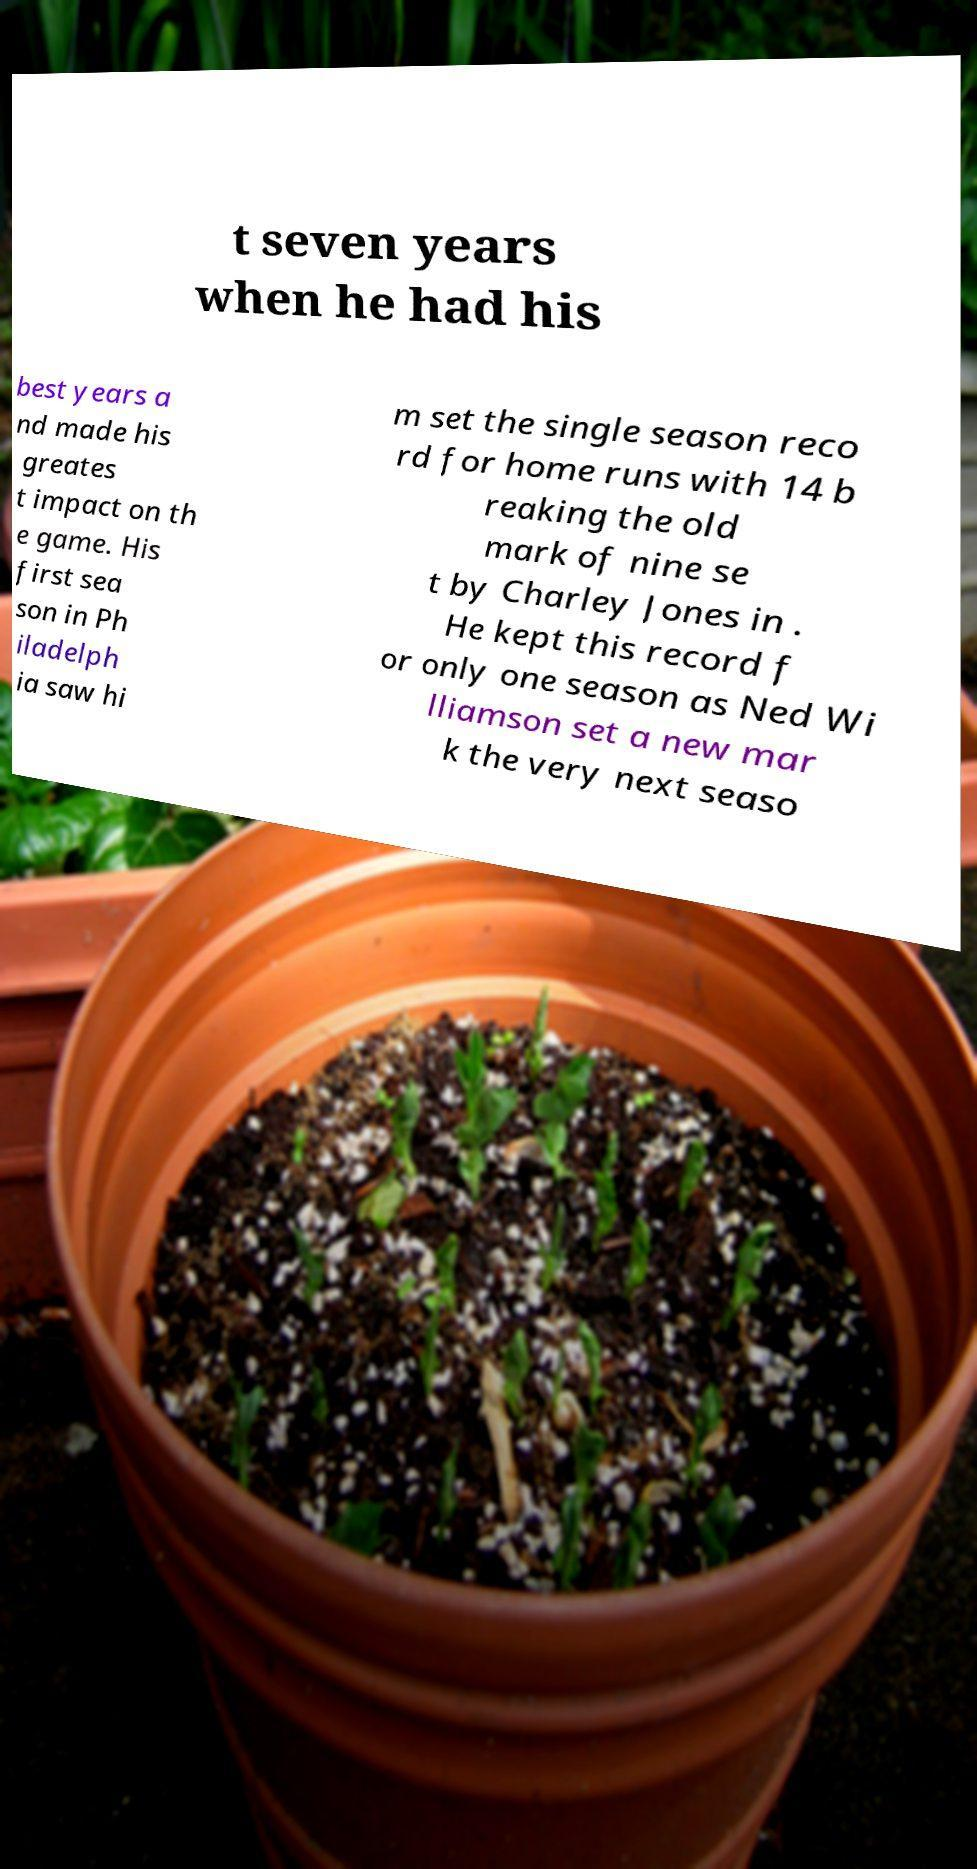For documentation purposes, I need the text within this image transcribed. Could you provide that? t seven years when he had his best years a nd made his greates t impact on th e game. His first sea son in Ph iladelph ia saw hi m set the single season reco rd for home runs with 14 b reaking the old mark of nine se t by Charley Jones in . He kept this record f or only one season as Ned Wi lliamson set a new mar k the very next seaso 